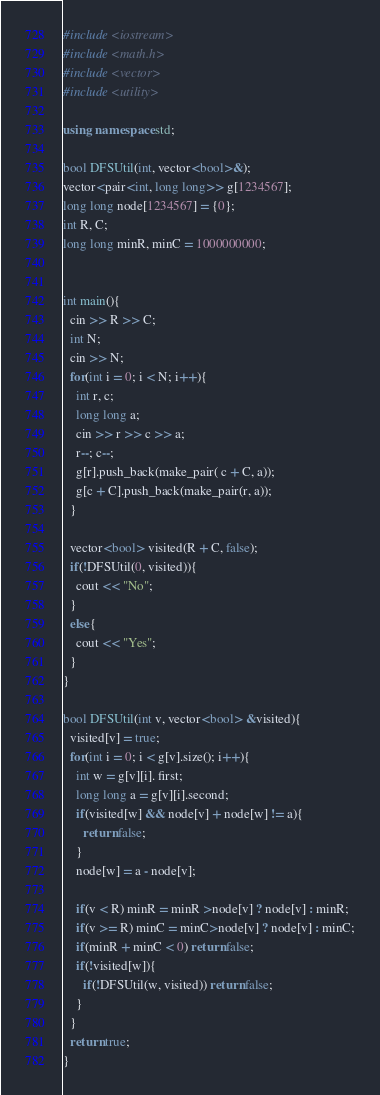Convert code to text. <code><loc_0><loc_0><loc_500><loc_500><_C++_>#include <iostream>
#include <math.h>
#include <vector>
#include <utility>
 
using namespace std;
 
bool DFSUtil(int, vector<bool>&);
vector<pair<int, long long>> g[1234567];
long long node[1234567] = {0};
int R, C;
long long minR, minC = 1000000000;
 
 
int main(){
  cin >> R >> C;
  int N;
  cin >> N;  
  for(int i = 0; i < N; i++){
    int r, c;
    long long a;
    cin >> r >> c >> a;
    r--; c--;
    g[r].push_back(make_pair( c + C, a));
    g[c + C].push_back(make_pair(r, a));
  }
 
  vector<bool> visited(R + C, false);
  if(!DFSUtil(0, visited)){
    cout << "No";
  }
  else{
    cout << "Yes";
  }
}
 
bool DFSUtil(int v, vector<bool> &visited){
  visited[v] = true;
  for(int i = 0; i < g[v].size(); i++){
    int w = g[v][i]. first;
    long long a = g[v][i].second;
    if(visited[w] && node[v] + node[w] != a){
      return false;
    }
    node[w] = a - node[v];
 
    if(v < R) minR = minR >node[v] ? node[v] : minR;
    if(v >= R) minC = minC>node[v] ? node[v] : minC;
    if(minR + minC < 0) return false;
    if(!visited[w]){
      if(!DFSUtil(w, visited)) return false;
    }
  }
  return true;
}</code> 